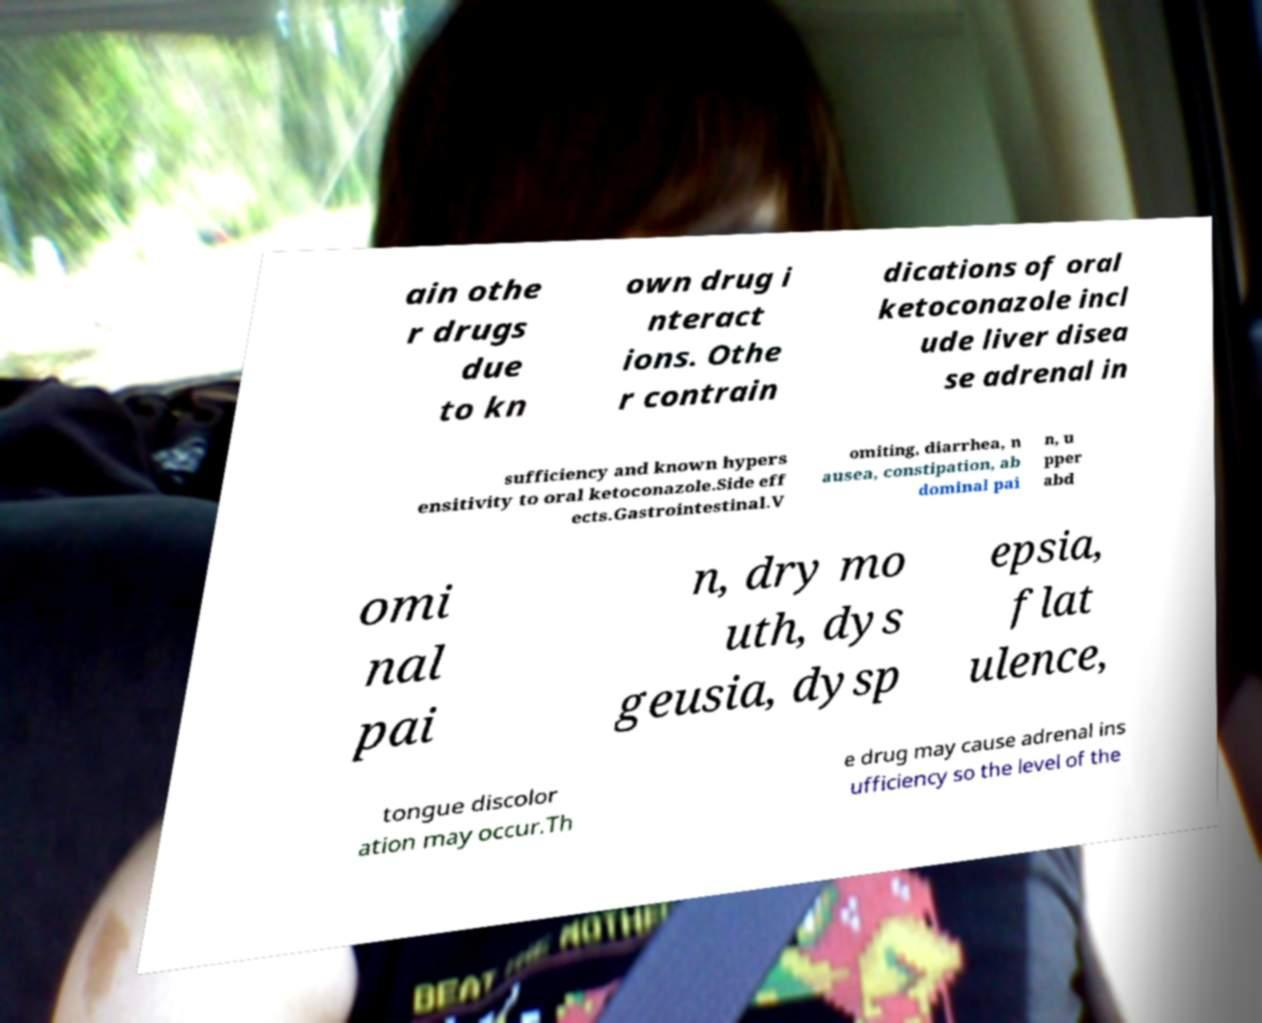For documentation purposes, I need the text within this image transcribed. Could you provide that? ain othe r drugs due to kn own drug i nteract ions. Othe r contrain dications of oral ketoconazole incl ude liver disea se adrenal in sufficiency and known hypers ensitivity to oral ketoconazole.Side eff ects.Gastrointestinal.V omiting, diarrhea, n ausea, constipation, ab dominal pai n, u pper abd omi nal pai n, dry mo uth, dys geusia, dysp epsia, flat ulence, tongue discolor ation may occur.Th e drug may cause adrenal ins ufficiency so the level of the 